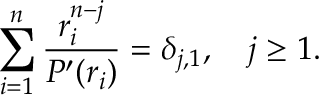<formula> <loc_0><loc_0><loc_500><loc_500>\sum _ { i = 1 } ^ { n } { \frac { r _ { i } ^ { n - j } } { P ^ { \prime } ( r _ { i } ) } } = \delta _ { j , 1 } , \quad j \geq 1 .</formula> 